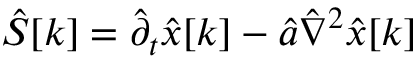<formula> <loc_0><loc_0><loc_500><loc_500>\hat { S } [ k ] = \hat { \partial } _ { t } \hat { x } [ k ] - \hat { a } \hat { \nabla } ^ { 2 } \hat { x } [ k ]</formula> 